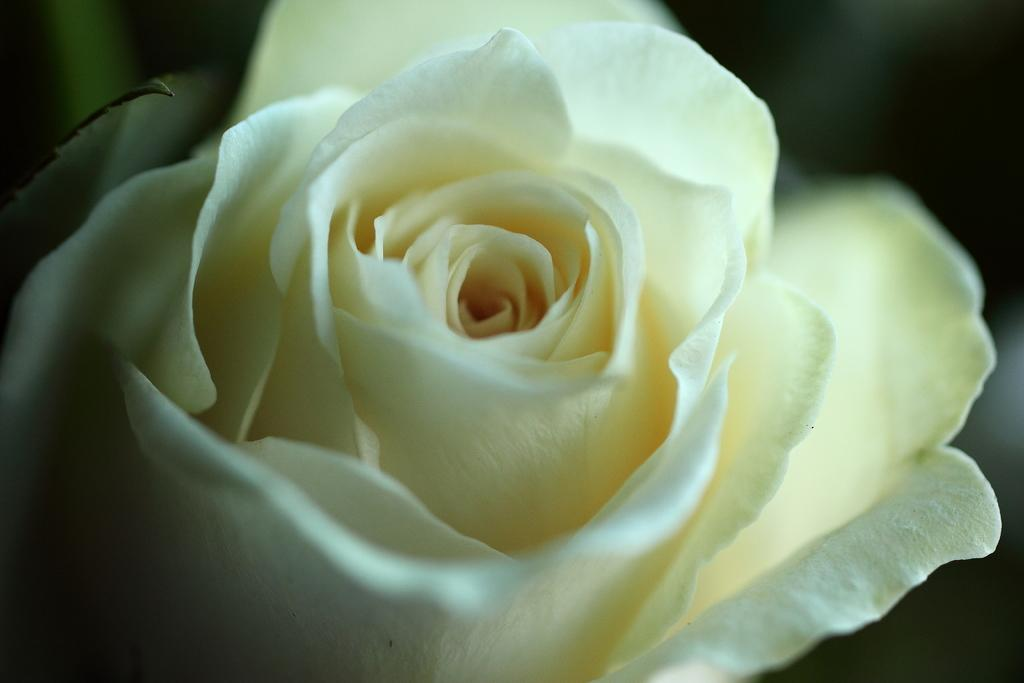What is the main subject of the image? There is a flower in the image. Can you describe the color of the flower? The flower is white in color. What can be observed about the background of the image? The background of the image is dark. Where is the kitty sitting in the image? There is no kitty present in the image. What is the afterthought of the person who took the picture? The provided facts do not give any information about the person who took the picture or their thoughts, so we cannot determine the afterthought. 